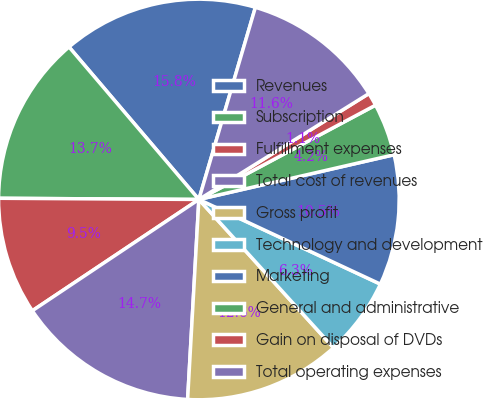Convert chart to OTSL. <chart><loc_0><loc_0><loc_500><loc_500><pie_chart><fcel>Revenues<fcel>Subscription<fcel>Fulfillment expenses<fcel>Total cost of revenues<fcel>Gross profit<fcel>Technology and development<fcel>Marketing<fcel>General and administrative<fcel>Gain on disposal of DVDs<fcel>Total operating expenses<nl><fcel>15.78%<fcel>13.68%<fcel>9.47%<fcel>14.73%<fcel>12.63%<fcel>6.32%<fcel>10.53%<fcel>4.22%<fcel>1.06%<fcel>11.58%<nl></chart> 